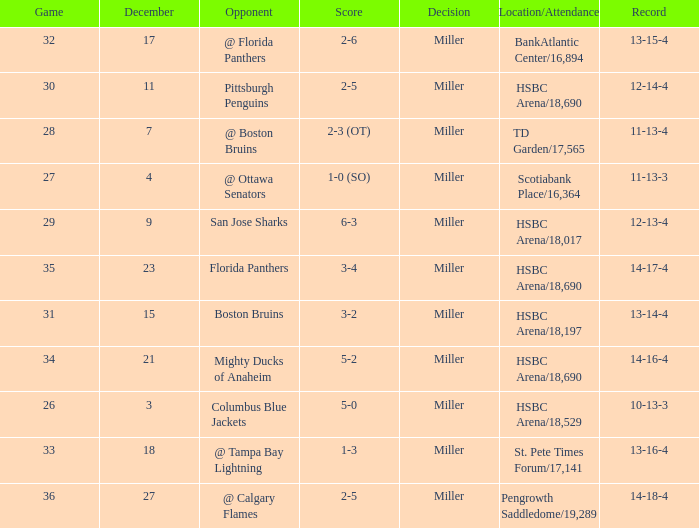Name the score for 29 game 6-3. 